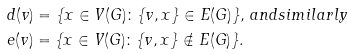Convert formula to latex. <formula><loc_0><loc_0><loc_500><loc_500>& d ( v ) = \{ x \in V ( G ) \colon \{ v , x \} \in E ( G ) \} , \, a n d s i m i l a r l y \\ & e ( v ) = \{ x \in V ( G ) \colon \{ v , x \} \notin E ( G ) \} .</formula> 